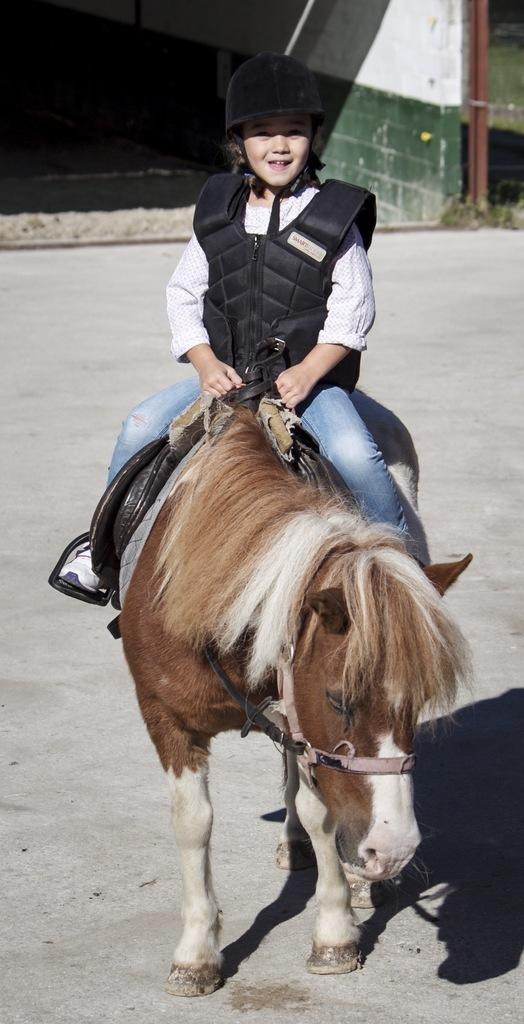What is the main subject of the image? The main subject of the image is a kid. What is the kid wearing on their head? The kid is wearing a black helmet. What is the kid doing in the image? The kid is sitting on a horse. What can be seen in the background of the image? There is a wall and a pole in the background of the image. What type of idea is the kid holding in their stomach in the image? There is no indication in the image that the kid is holding an idea in their stomach, as ideas are abstract concepts and cannot be physically held. 